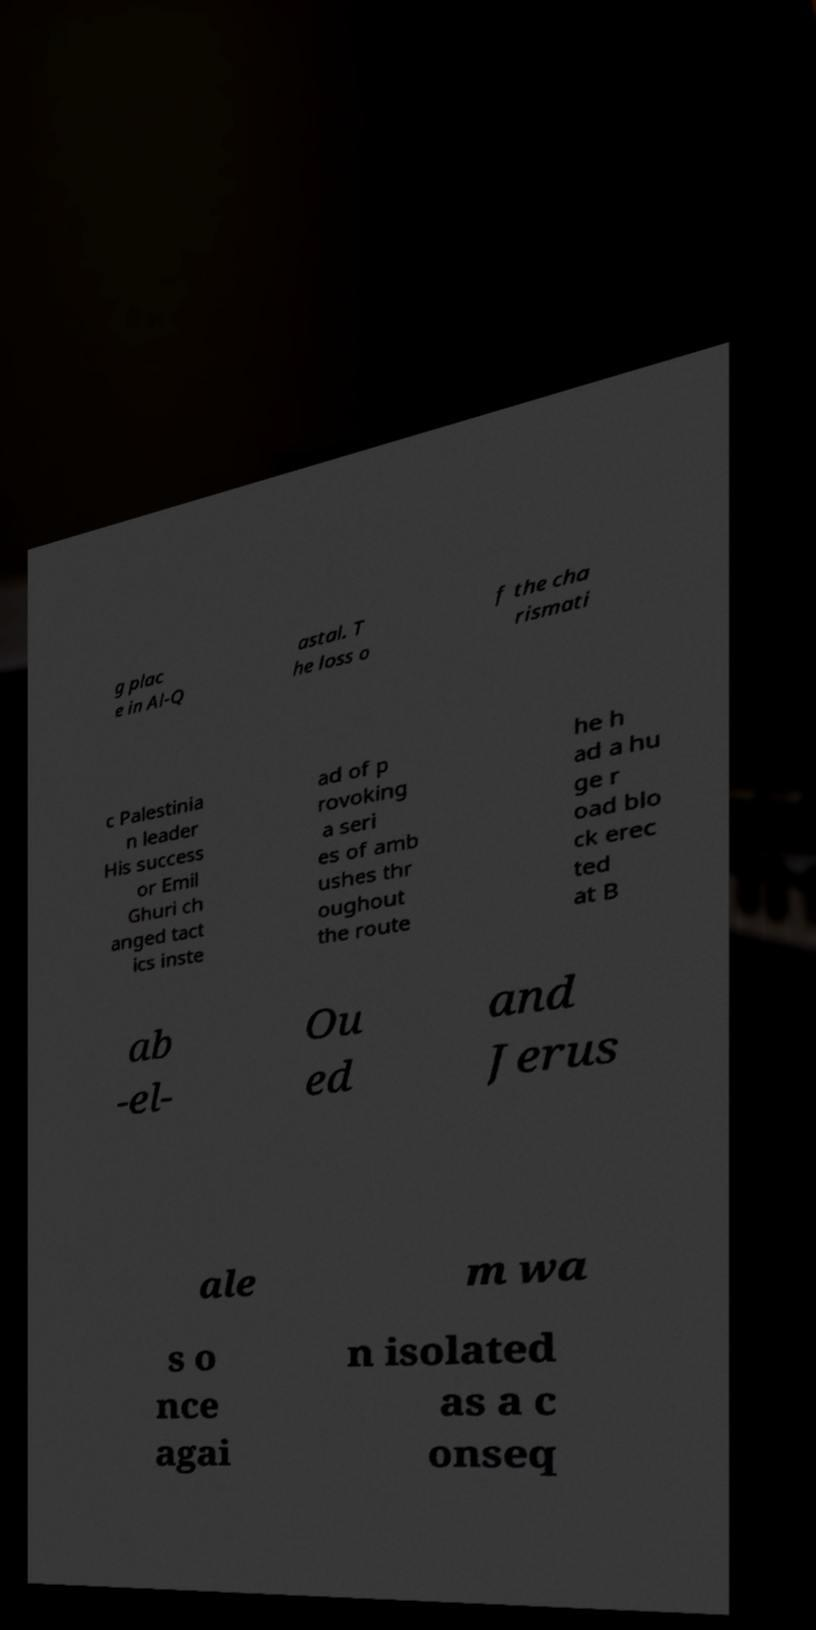Can you read and provide the text displayed in the image?This photo seems to have some interesting text. Can you extract and type it out for me? g plac e in Al-Q astal. T he loss o f the cha rismati c Palestinia n leader His success or Emil Ghuri ch anged tact ics inste ad of p rovoking a seri es of amb ushes thr oughout the route he h ad a hu ge r oad blo ck erec ted at B ab -el- Ou ed and Jerus ale m wa s o nce agai n isolated as a c onseq 